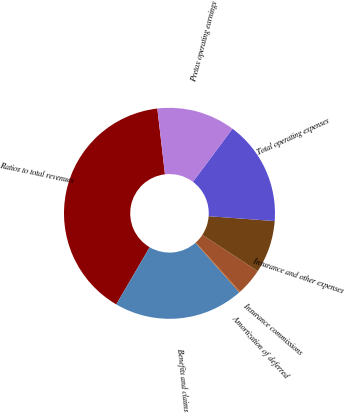Convert chart. <chart><loc_0><loc_0><loc_500><loc_500><pie_chart><fcel>Ratios to total revenues<fcel>Benefits and claims<fcel>Amortization of deferred<fcel>Insurance commissions<fcel>Insurance and other expenses<fcel>Total operating expenses<fcel>Pretax operating earnings<nl><fcel>39.74%<fcel>19.94%<fcel>0.14%<fcel>4.1%<fcel>8.06%<fcel>15.98%<fcel>12.02%<nl></chart> 